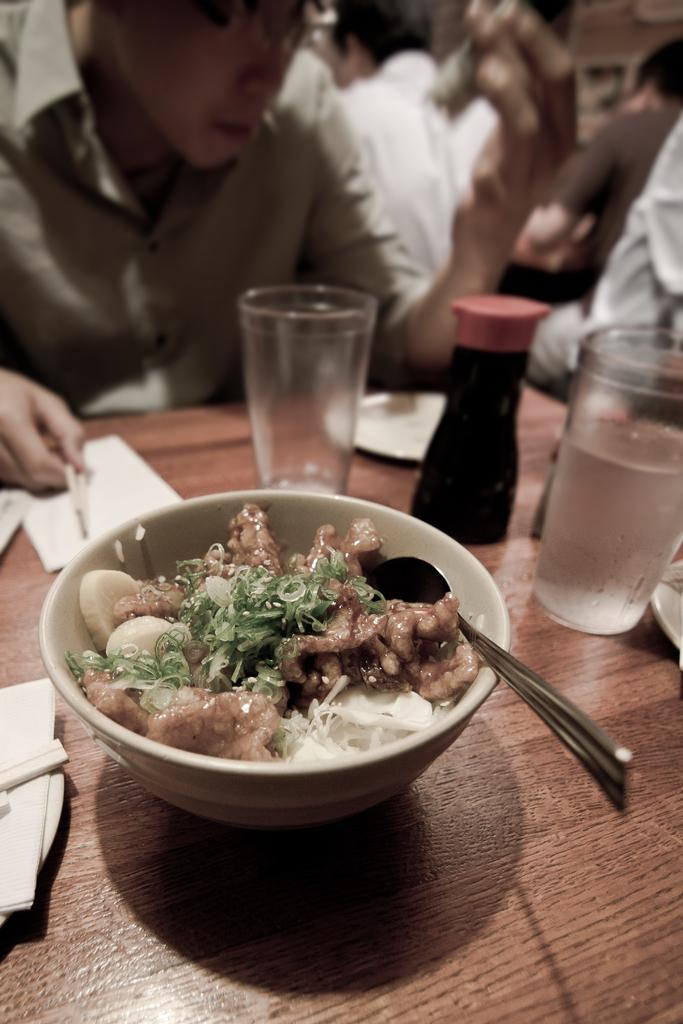What are the persons in the image wearing? The persons in the image are wearing clothes. What is located in the middle of the image? There is a table in the middle of the image. What items can be seen on the table? Glasses, papers, a bottle, and a bowl with food are present on the table. What type of club is being used by the persons in the image? There is no club present in the image; the persons are wearing clothes and there is a table with various items on it. 